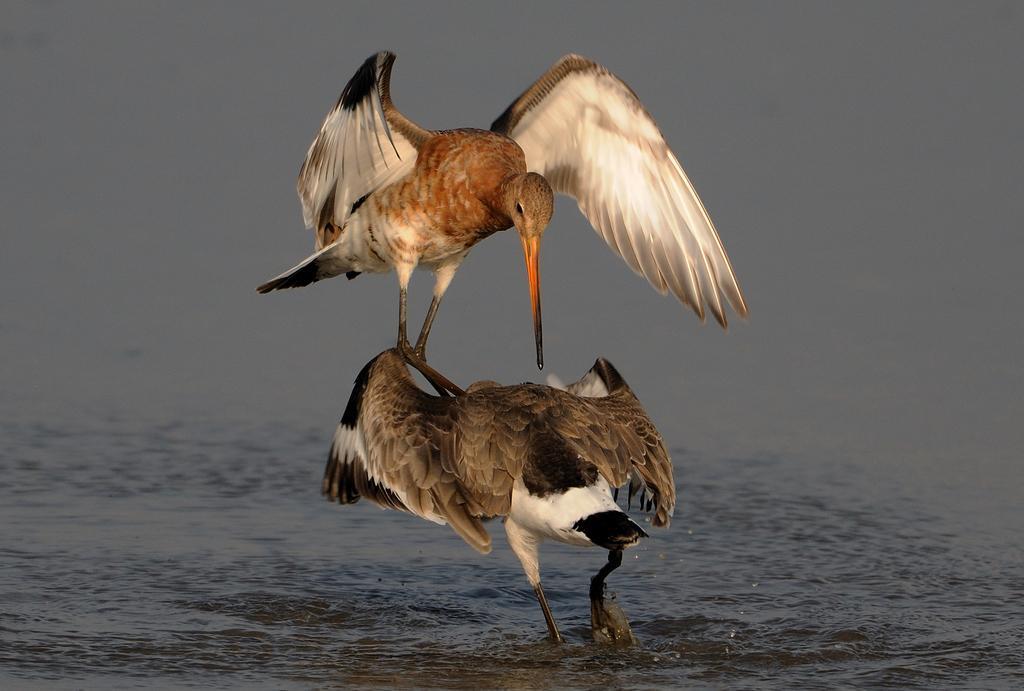How would you summarize this image in a sentence or two? As we can see in the image there are birds, water and sky. 